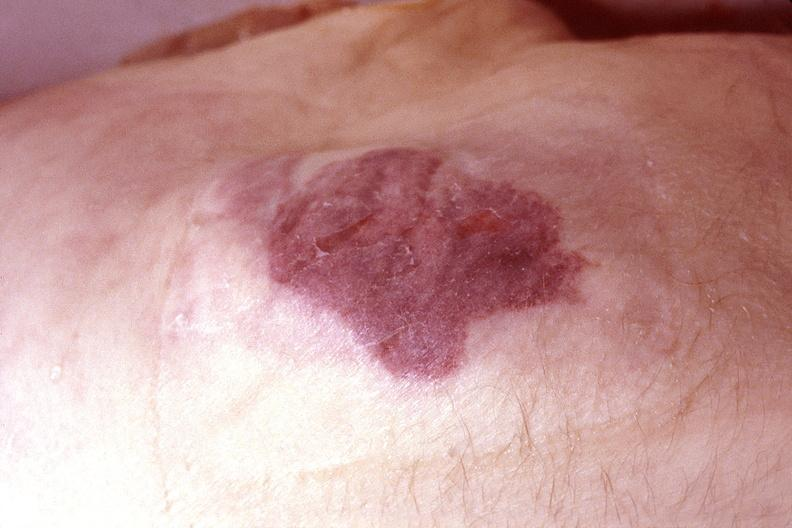what does this image show?
Answer the question using a single word or phrase. Skin 